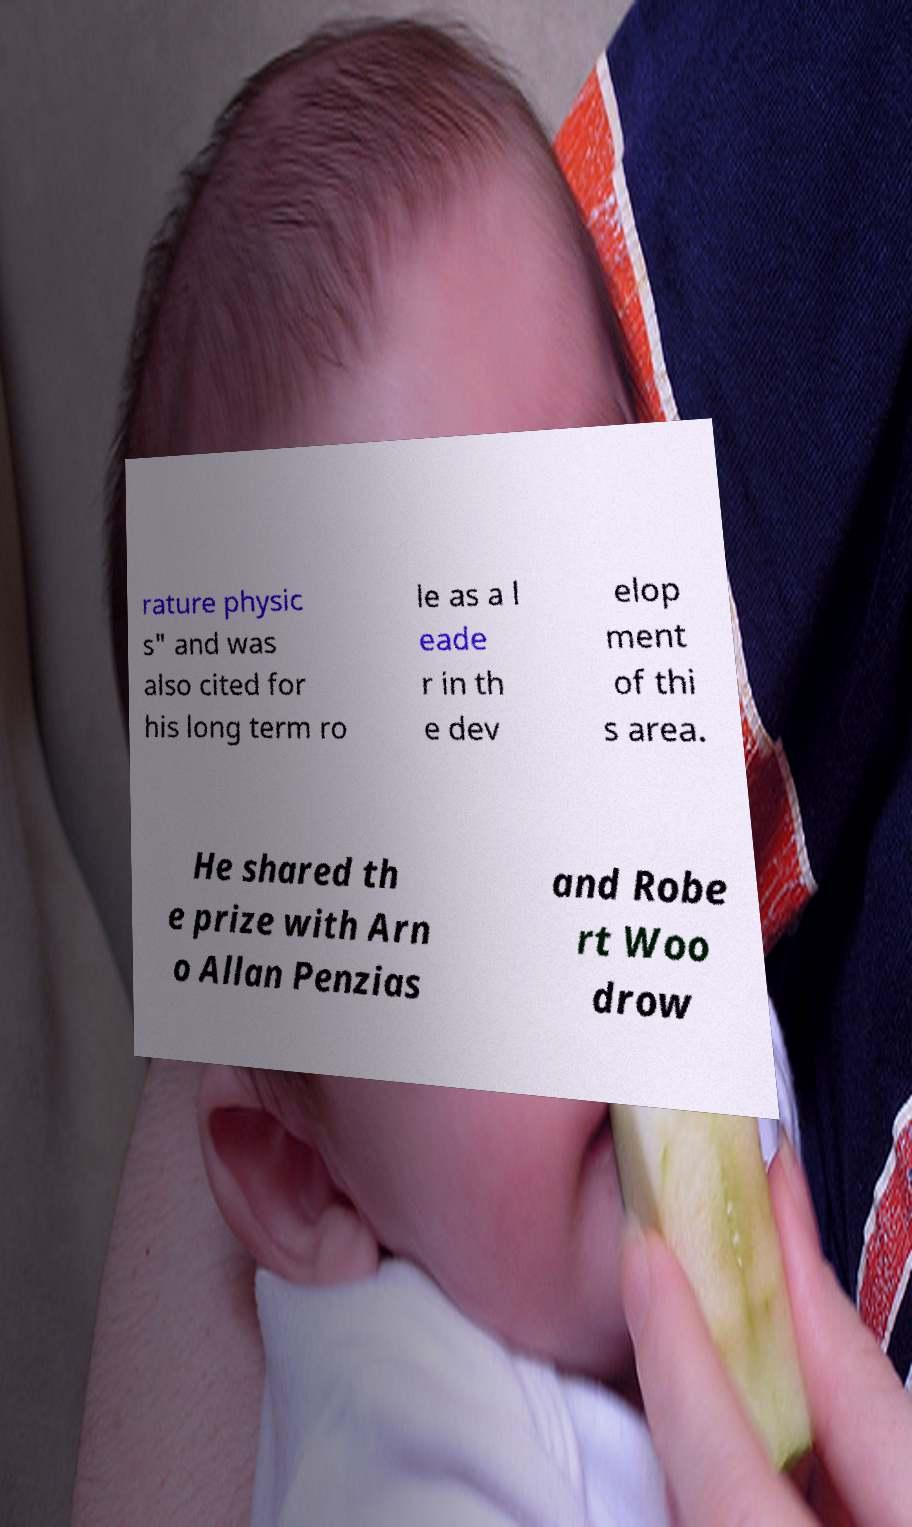Please read and relay the text visible in this image. What does it say? rature physic s" and was also cited for his long term ro le as a l eade r in th e dev elop ment of thi s area. He shared th e prize with Arn o Allan Penzias and Robe rt Woo drow 